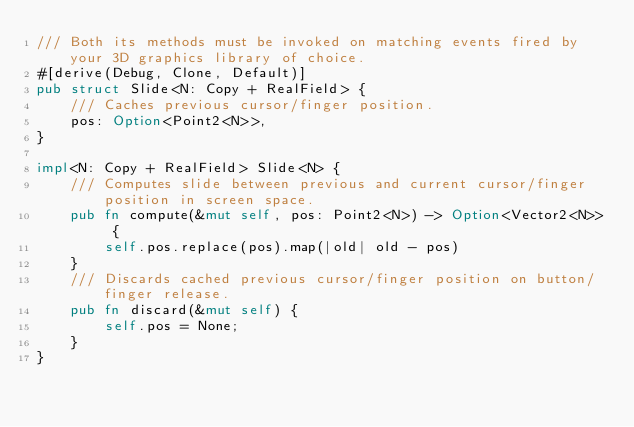<code> <loc_0><loc_0><loc_500><loc_500><_Rust_>/// Both its methods must be invoked on matching events fired by your 3D graphics library of choice.
#[derive(Debug, Clone, Default)]
pub struct Slide<N: Copy + RealField> {
	/// Caches previous cursor/finger position.
	pos: Option<Point2<N>>,
}

impl<N: Copy + RealField> Slide<N> {
	/// Computes slide between previous and current cursor/finger position in screen space.
	pub fn compute(&mut self, pos: Point2<N>) -> Option<Vector2<N>> {
		self.pos.replace(pos).map(|old| old - pos)
	}
	/// Discards cached previous cursor/finger position on button/finger release.
	pub fn discard(&mut self) {
		self.pos = None;
	}
}
</code> 